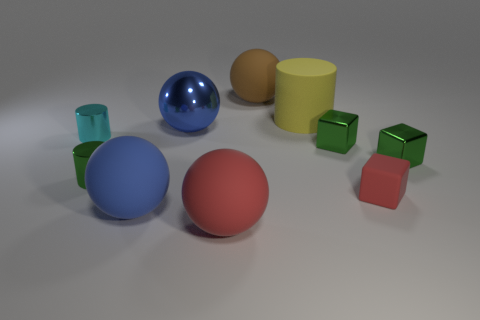How many cylinders are large objects or red rubber objects?
Keep it short and to the point. 1. There is a red rubber object left of the big brown sphere; how many tiny green shiny objects are on the right side of it?
Keep it short and to the point. 2. Are the yellow thing and the big red object made of the same material?
Keep it short and to the point. Yes. Are there any large brown objects made of the same material as the tiny cyan cylinder?
Provide a succinct answer. No. There is a large matte cylinder that is on the right side of the blue sphere in front of the tiny green metal thing to the left of the big brown object; what color is it?
Your answer should be very brief. Yellow. How many purple things are either big rubber spheres or metallic blocks?
Offer a terse response. 0. How many purple rubber things are the same shape as the cyan shiny thing?
Give a very brief answer. 0. The brown matte thing that is the same size as the yellow rubber object is what shape?
Your answer should be compact. Sphere. Are there any small red cubes behind the rubber cylinder?
Your answer should be very brief. No. Is there a large red object that is in front of the large rubber sphere behind the green cylinder?
Keep it short and to the point. Yes. 